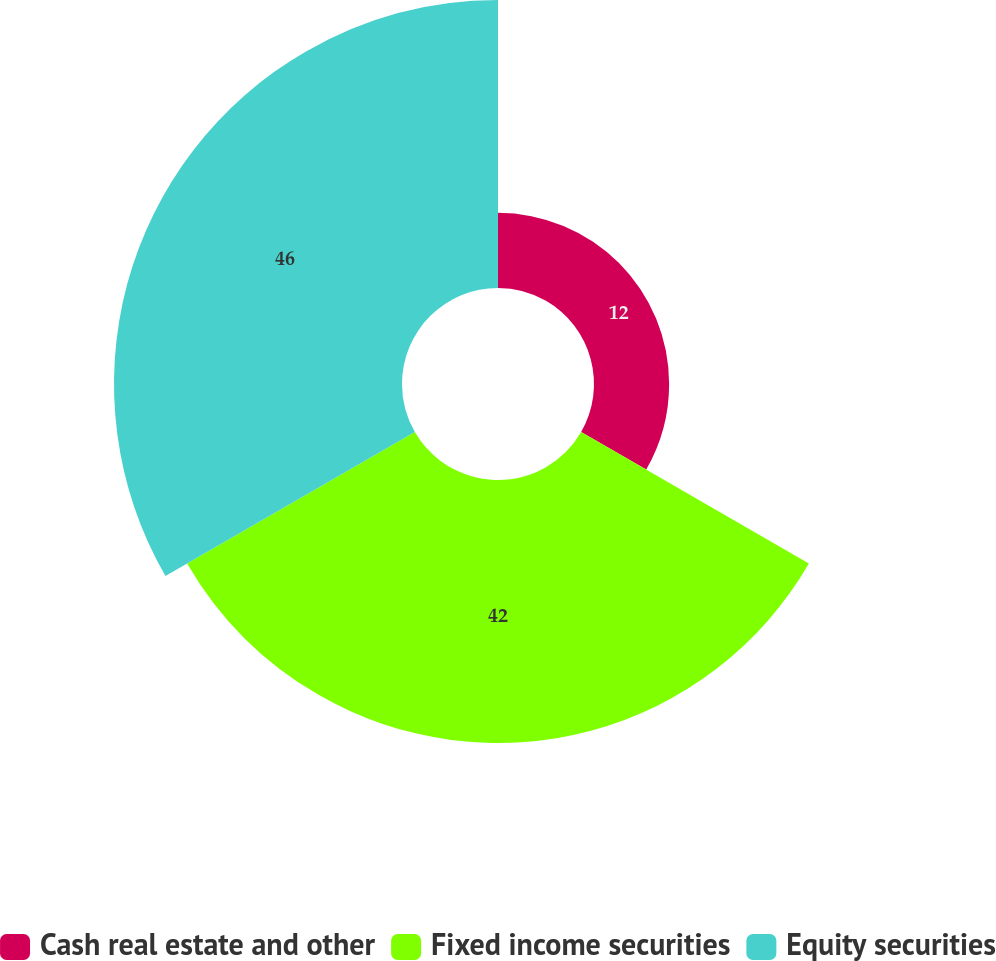Convert chart to OTSL. <chart><loc_0><loc_0><loc_500><loc_500><pie_chart><fcel>Cash real estate and other<fcel>Fixed income securities<fcel>Equity securities<nl><fcel>12.0%<fcel>42.0%<fcel>46.0%<nl></chart> 